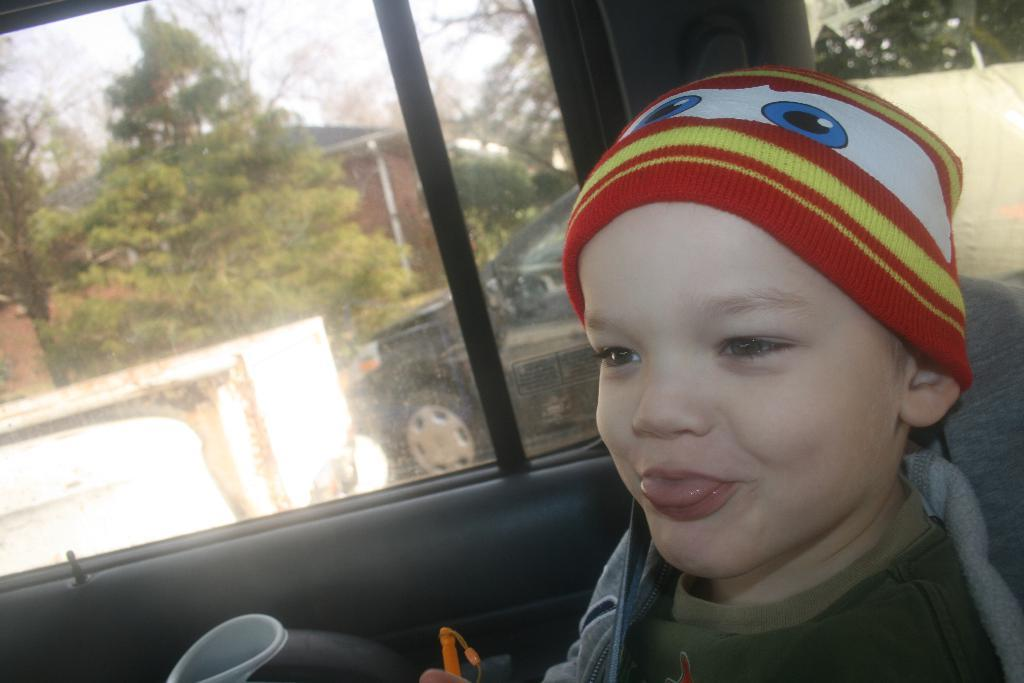What is the main subject in the foreground of the image? There is a small boy in a vehicle in the foreground. What can be seen in the background of the image? There are trees, houses, vehicles, and the sky visible in the background. How many types of objects are present in the background? There are four types of objects present in the background: trees, houses, vehicles, and the sky. What type of copper is the small boy using to play with in the vehicle? There is no copper present in the image, and the small boy is not playing with any toys. How does the small boy's stomach feel while he is in the vehicle? There is no information about the small boy's stomach in the image, so we cannot determine how he feels. 